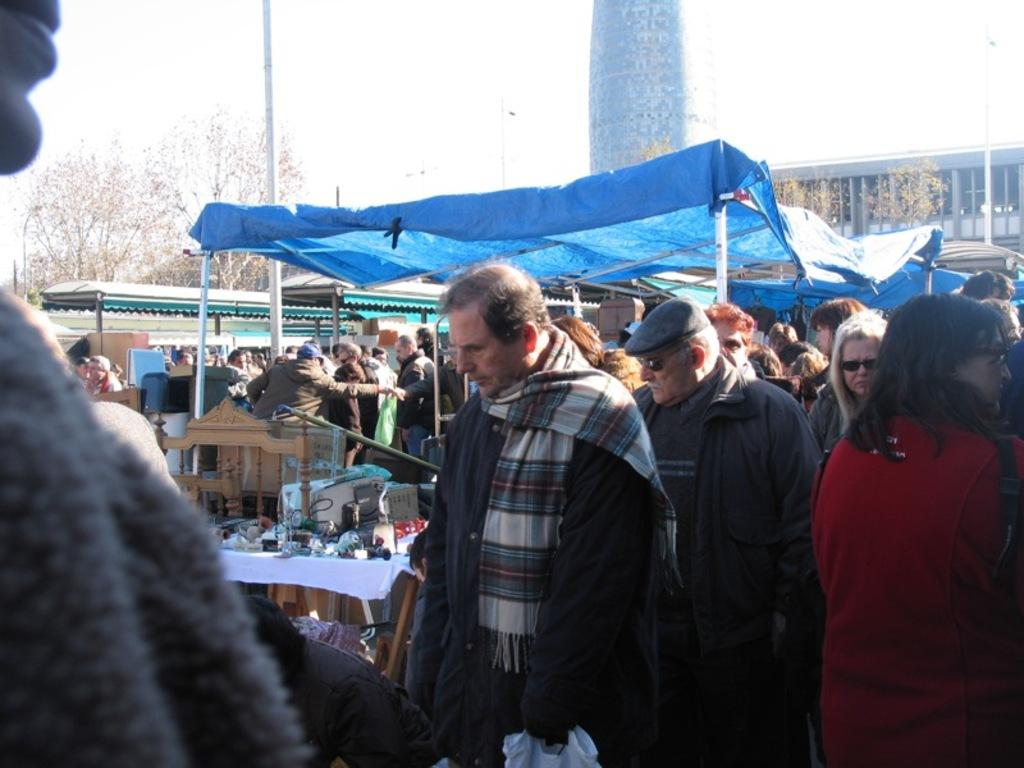What is happening in the image? There is a group of people standing in the image. What can be seen in the background of the image? There are objects on a table and green trees in the background. What type of shelter is visible in the image? There is a blue tent in the image. What is the color of the sky in the image? The sky appears to be white in color. What type of parcel is being delivered to the group of people in the image? There is no parcel being delivered to the group of people in the image. What type of party is taking place in the image? There is no party taking place in the image; it simply shows a group of people standing together. 